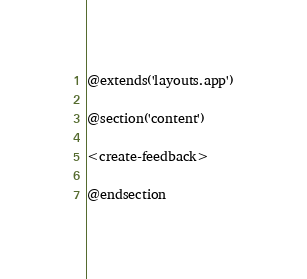Convert code to text. <code><loc_0><loc_0><loc_500><loc_500><_PHP_>@extends('layouts.app')

@section('content')

<create-feedback>

@endsection</code> 